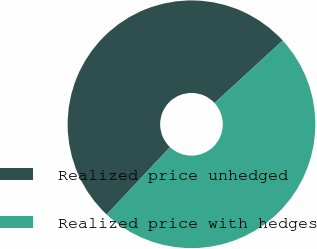Convert chart to OTSL. <chart><loc_0><loc_0><loc_500><loc_500><pie_chart><fcel>Realized price unhedged<fcel>Realized price with hedges<nl><fcel>51.18%<fcel>48.82%<nl></chart> 